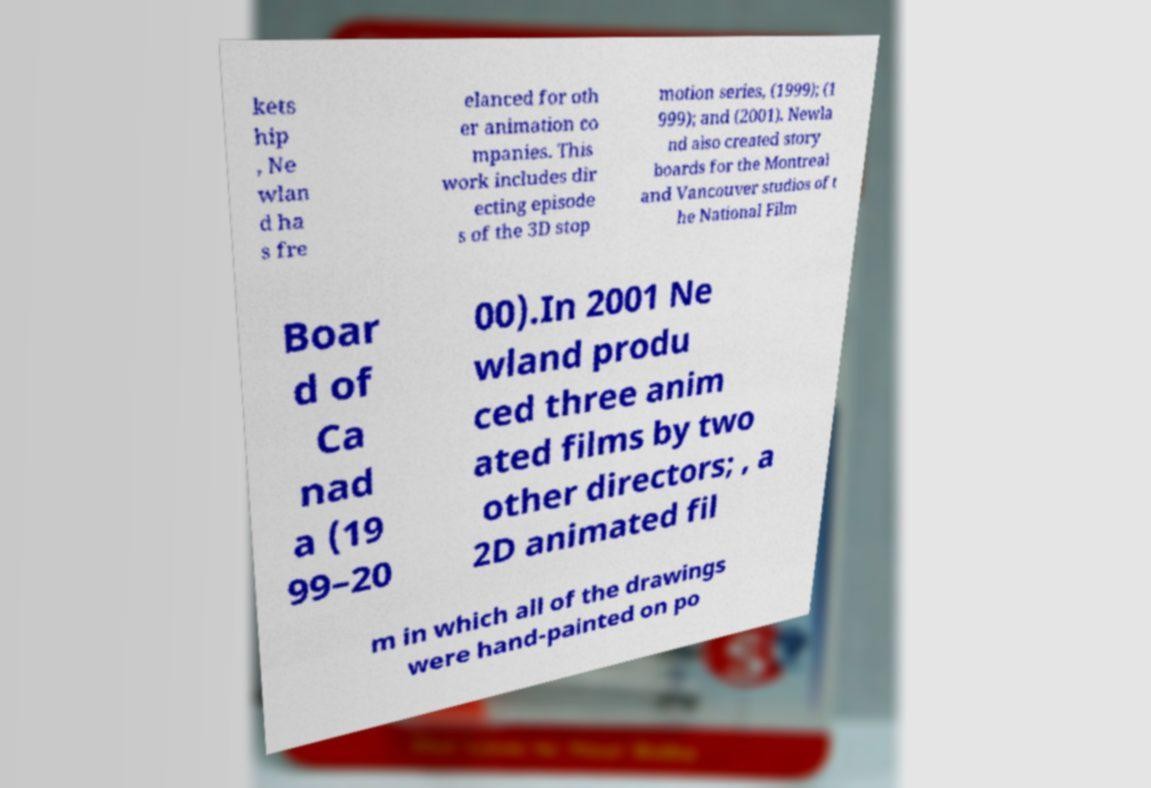Please identify and transcribe the text found in this image. kets hip , Ne wlan d ha s fre elanced for oth er animation co mpanies. This work includes dir ecting episode s of the 3D stop motion series, (1999); (1 999); and (2001). Newla nd also created story boards for the Montreal and Vancouver studios of t he National Film Boar d of Ca nad a (19 99–20 00).In 2001 Ne wland produ ced three anim ated films by two other directors; , a 2D animated fil m in which all of the drawings were hand-painted on po 